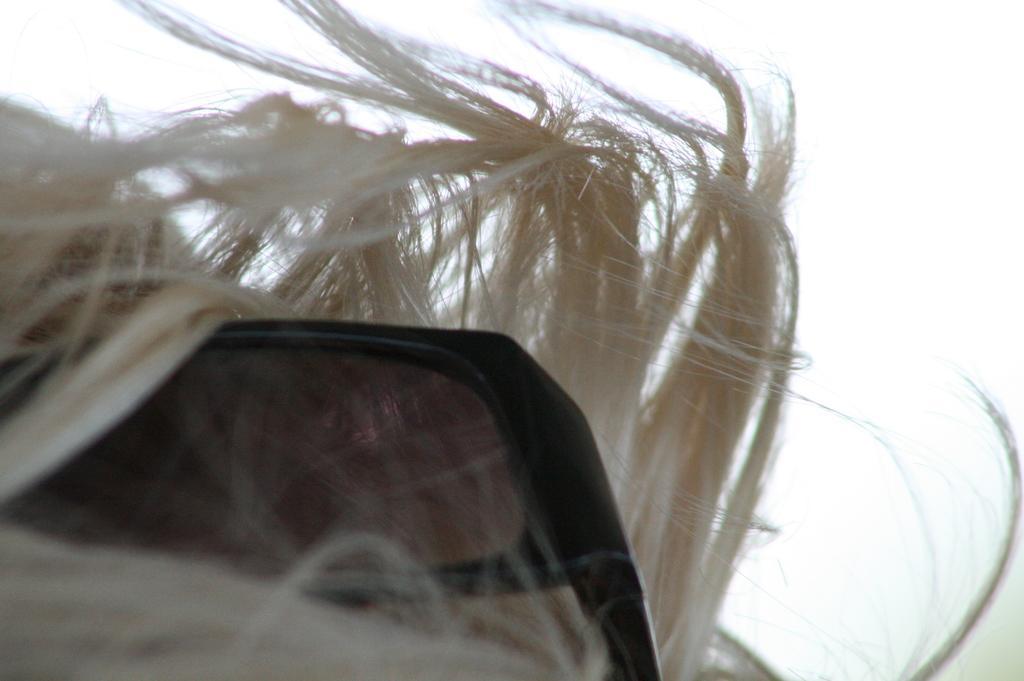Could you give a brief overview of what you see in this image? This picture shows human hair and sunglasses and we see a cloudy sky. 